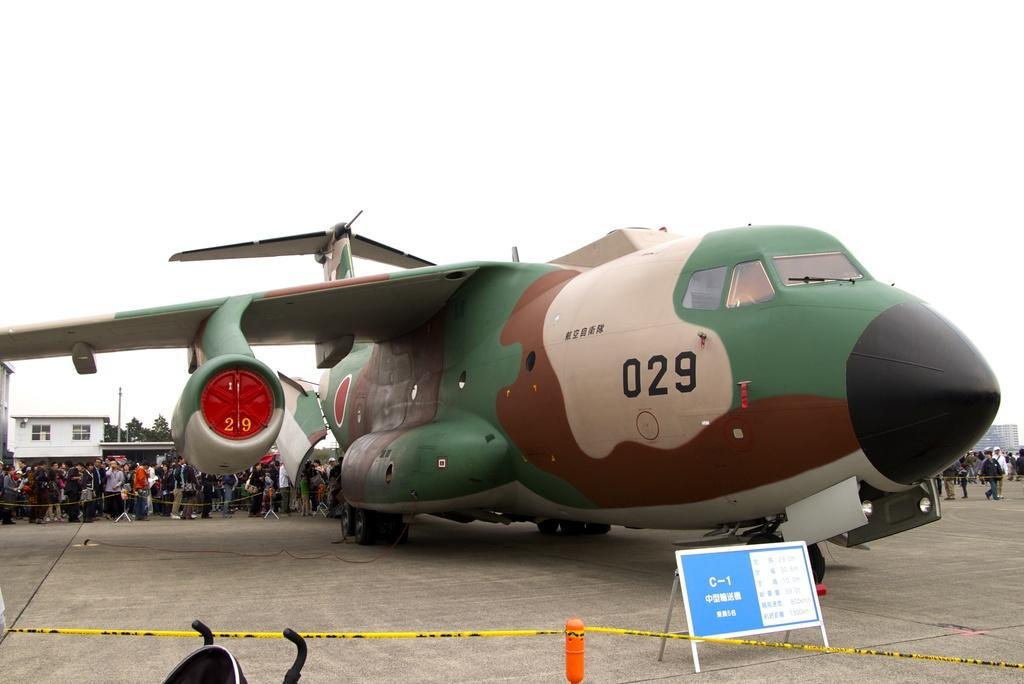Please provide a concise description of this image. In this image I can see a board, an orange color thing and a yellow color tape in the front. I can also see a black color thing on the bottom left side and in the background I can see a camouflage color aircraft and number of people are standing behind it. I can also see few buildings on the both side of this image and on the left side I can see few trees. 